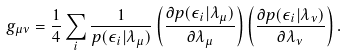Convert formula to latex. <formula><loc_0><loc_0><loc_500><loc_500>g _ { \mu \nu } = \frac { 1 } { 4 } \sum _ { i } \frac { 1 } { p ( \epsilon _ { i } | \lambda _ { \mu } ) } \left ( \frac { \partial p ( \epsilon _ { i } | \lambda _ { \mu } ) } { \partial \lambda _ { \mu } } \right ) \left ( \frac { \partial p ( \epsilon _ { i } | \lambda _ { \nu } ) } { \partial \lambda _ { \nu } } \right ) .</formula> 